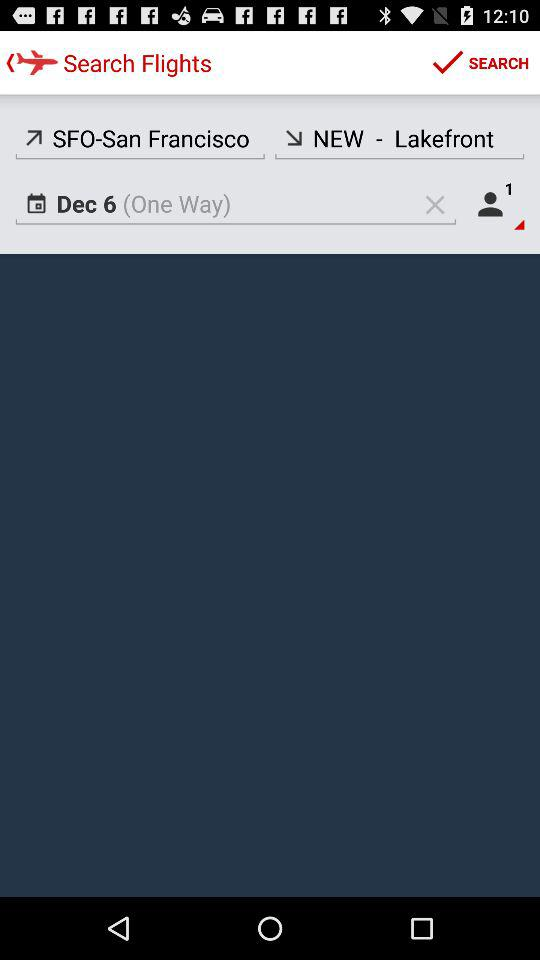What's the selected date of the journey? The selected date of the journey is December 6. 